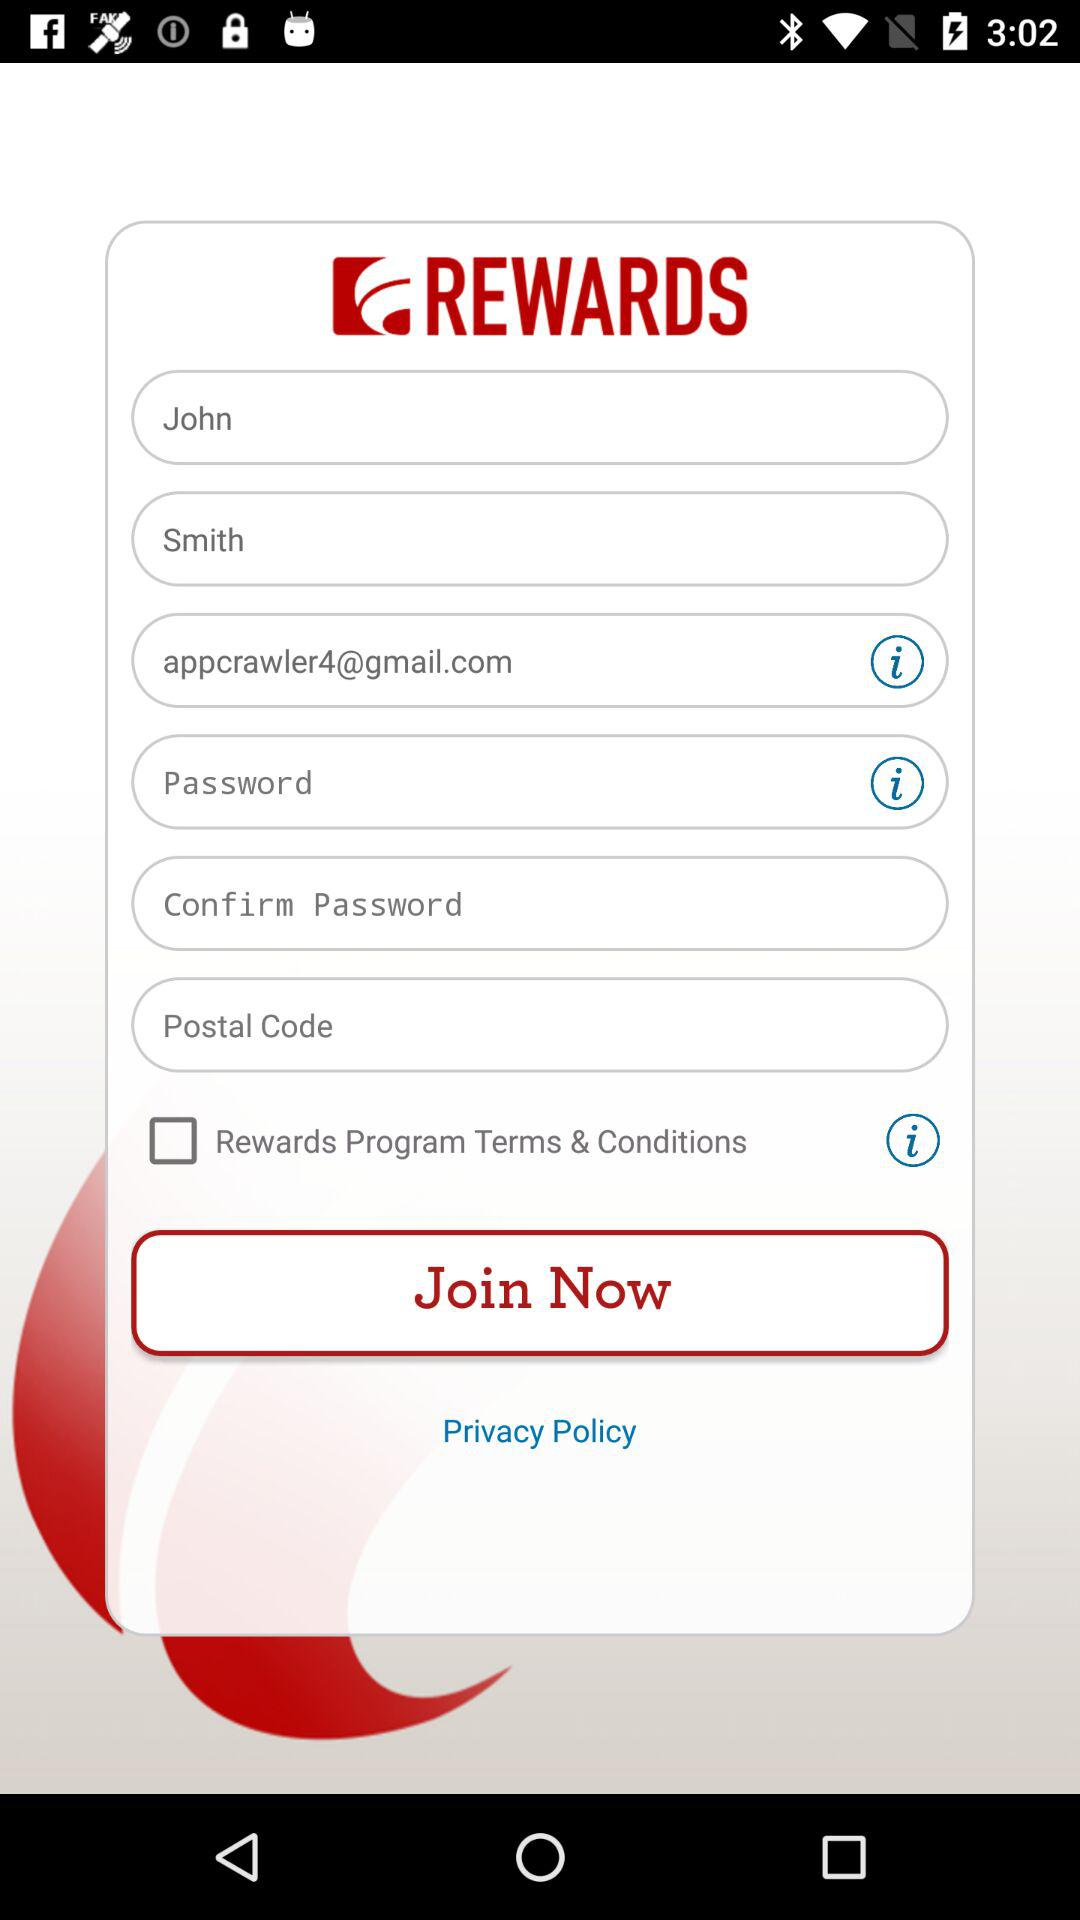What is the name of the application? The name of the application is "REWARDS". 